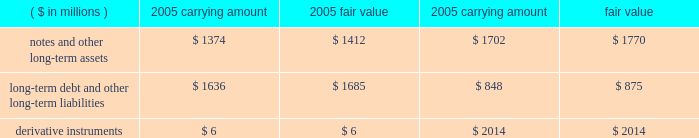Fair value of financial instruments we believe that the fair values of current assets and current liabilities approximate their reported carrying amounts .
The fair values of non-current financial assets , liabilities and derivatives are shown in the table. .
We value notes and other receivables based on the expected future cash flows dis- counted at risk-adjusted rates .
We determine valuations for long-term debt and other long-term liabilities based on quoted market prices or expected future payments dis- counted at risk-adjusted rates .
Derivative instruments during 2003 , we entered into an interest rate swap agreement under which we receive a floating rate of interest and pay a fixed rate of interest .
The swap modifies our interest rate exposure by effectively converting a note receivable with a fixed rate to a floating rate .
The aggregate notional amount of the swap is $ 92 million and it matures in 2010 .
The swap is classified as a fair value hedge under fas no .
133 , 201caccounting for derivative instruments and hedging activities 201d ( 201cfas no .
133 201d ) , and the change in the fair value of the swap , as well as the change in the fair value of the underlying note receivable , is recognized in interest income .
The fair value of the swap was a $ 1 million asset at year-end 2005 , and a $ 3 million liability at year-end 2004 .
The hedge is highly effective , and therefore , no net gain or loss was reported during 2005 , 2004 , and 2003 .
During 2005 , we entered into two interest rate swap agreements to manage the volatil- ity of the u.s .
Treasury component of the interest rate risk associated with the forecasted issuance our series f senior notes and the exchange of our series c and e senior notes for new series g senior notes .
Both swaps were designated as cash flow hedges under fas no .
133 and were terminated upon pricing of the notes .
Both swaps were highly effective in offsetting fluctuations in the u.s .
Treasury component .
Thus , there was no net gain or loss reported in earnings during 2005 .
The total amount for these swaps was recorded in other comprehensive income and was a net loss of $ 2 million during 2005 , which will be amortized to interest expense using the interest method over the life of the notes .
At year-end 2005 , we had six outstanding interest rate swap agreements to manage interest rate risk associated with the residual interests we retain in conjunction with our timeshare note sales .
Historically , we were required by purchasers and/or rating agen- cies to utilize interest rate swaps to protect the excess spread within our sold note pools .
The aggregate notional amount of the swaps is $ 380 million , and they expire through 2022 .
These swaps are not accounted for as hedges under fas no .
133 .
The fair value of the swaps is a net asset of $ 5 million at year-end 2005 , and a net asset of approximately $ 3 million at year-end 2004 .
We recorded a $ 2 million net gain during 2005 and 2004 , and a $ 3 million net gain during 2003 .
During 2005 , 2004 , and 2003 , we entered into interest rate swaps to manage interest rate risk associated with forecasted timeshare note sales .
During 2005 , one swap was designated as a cash flow hedge under fas no .
133 and was highly effective in offsetting interest rate fluctuations .
The amount of the ineffectiveness is immaterial .
The second swap entered into in 2005 did not qualify for hedge accounting .
The non-qualifying swaps resulted in a loss of $ 3 million during 2005 , a gain of $ 2 million during 2004 and a loss of $ 4 million during 2003 .
These amounts are included in the gains from the sales of timeshare notes receivable .
During 2005 , 2004 , and 2003 , we entered into forward foreign exchange contracts to manage the foreign currency exposure related to certain monetary assets .
The aggregate dollar equivalent of the notional amount of the contracts is $ 544 million at year-end 2005 .
The forward exchange contracts do not qualify as hedges in accordance with fas no .
133 .
The fair value of the forward contracts is a liability of $ 2 million at year-end 2005 and zero at year-end 2004 .
We recorded a $ 26 million gain during 2005 and a $ 3 million and $ 2 million net loss during 2004 and 2003 , respectively , relating to these forward foreign exchange contracts .
The net gains and losses for all years were offset by income and losses recorded from translating the related monetary assets denominated in foreign currencies into u.s .
Dollars .
During 2005 , 2004 , and 2003 , we entered into foreign exchange option and forward contracts to hedge the potential volatility of earnings and cash flows associated with variations in foreign exchange rates .
The aggregate dollar equivalent of the notional amounts of the contracts is $ 27 million at year-end 2005 .
These contracts have terms of less than one year and are classified as cash flow hedges .
Changes in their fair values are recorded as a component of other comprehensive income .
The fair value of the option contracts is approximately zero at year-end 2005 and 2004 .
During 2004 , it was deter- mined that certain derivatives were no longer effective in offsetting the hedged item .
Thus , cash flow hedge accounting treatment was discontinued and the ineffective con- tracts resulted in a loss of $ 1 million , which was reported in earnings for 2004 .
The remaining hedges were highly effective and there was no net gain or loss reported in earnings for 2005 , 2004 , and 2003 .
As of year-end 2005 , there were no deferred gains or losses on existing contracts accumulated in other comprehensive income that we expect to reclassify into earnings over the next year .
During 2005 , we entered into forward foreign exchange contracts to manage currency exchange rate volatility associated with certain investments in foreign operations .
One contract was designated as a hedge in the net investment of a foreign operation under fas no .
133 .
The hedge was highly effective and resulted in a $ 1 million net loss in the cumulative translation adjustment at year-end 2005 .
Certain contracts did not qualify as hedges under fas no .
133 and resulted in a gain of $ 3 million for 2005 .
The contracts offset the losses associated with translation adjustments for various investments in for- eign operations .
The contracts have an aggregate dollar equivalent of the notional amounts of $ 229 million and a fair value of approximately zero at year-end 2005 .
Contingencies guarantees we issue guarantees to certain lenders and hotel owners primarily to obtain long-term management contracts .
The guarantees generally have a stated maximum amount of funding and a term of five years or less .
The terms of guarantees to lenders generally require us to fund if cash flows from hotel operations are inadequate to cover annual debt service or to repay the loan at the end of the term .
The terms of the guarantees to hotel owners generally require us to fund if the hotels do not attain specified levels of 5 0 | m a r r i o t t i n t e r n a t i o n a l , i n c .
2 0 0 5 .
What is the potential gain if the notes and other long-term assets had been sold at the end of 2004? 
Computations: (1770 - 1702)
Answer: 68.0. 